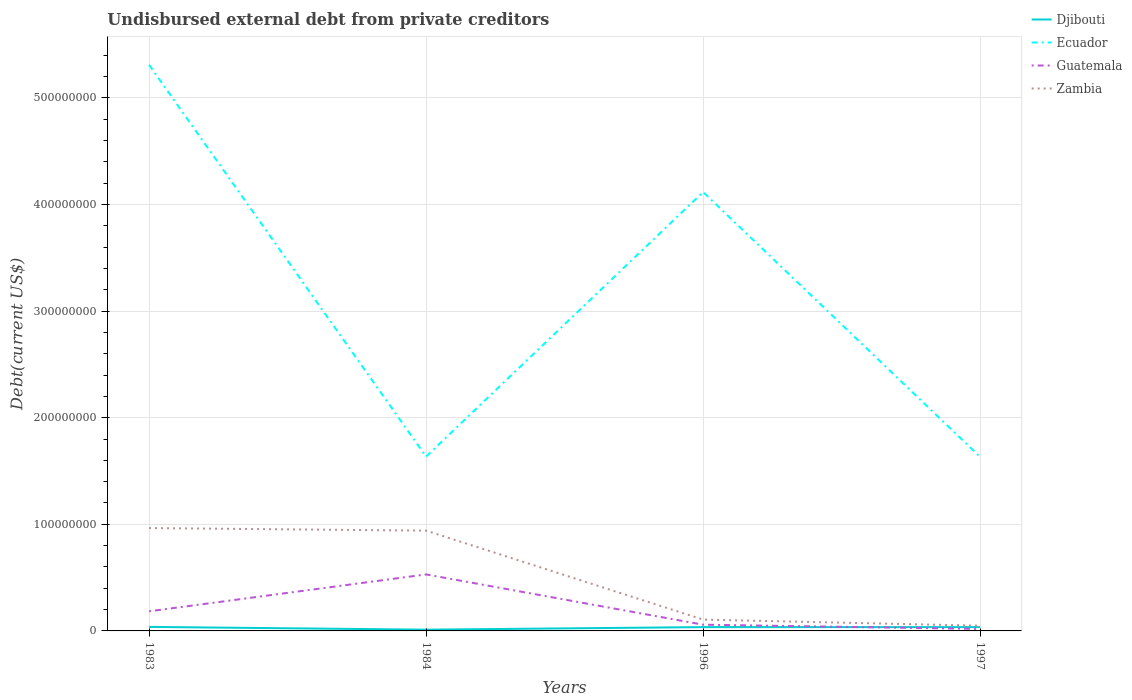Does the line corresponding to Ecuador intersect with the line corresponding to Djibouti?
Make the answer very short. No. Across all years, what is the maximum total debt in Djibouti?
Provide a short and direct response. 1.19e+06. In which year was the total debt in Guatemala maximum?
Give a very brief answer. 1997. What is the total total debt in Zambia in the graph?
Offer a very short reply. 5.72e+06. What is the difference between the highest and the second highest total debt in Djibouti?
Offer a terse response. 2.57e+06. Is the total debt in Guatemala strictly greater than the total debt in Ecuador over the years?
Your answer should be compact. Yes. Where does the legend appear in the graph?
Offer a terse response. Top right. What is the title of the graph?
Give a very brief answer. Undisbursed external debt from private creditors. What is the label or title of the Y-axis?
Your response must be concise. Debt(current US$). What is the Debt(current US$) of Djibouti in 1983?
Offer a terse response. 3.77e+06. What is the Debt(current US$) of Ecuador in 1983?
Your response must be concise. 5.31e+08. What is the Debt(current US$) of Guatemala in 1983?
Ensure brevity in your answer.  1.84e+07. What is the Debt(current US$) in Zambia in 1983?
Make the answer very short. 9.65e+07. What is the Debt(current US$) in Djibouti in 1984?
Your response must be concise. 1.19e+06. What is the Debt(current US$) of Ecuador in 1984?
Offer a terse response. 1.64e+08. What is the Debt(current US$) in Guatemala in 1984?
Your answer should be compact. 5.30e+07. What is the Debt(current US$) of Zambia in 1984?
Provide a succinct answer. 9.41e+07. What is the Debt(current US$) in Djibouti in 1996?
Keep it short and to the point. 3.57e+06. What is the Debt(current US$) of Ecuador in 1996?
Provide a succinct answer. 4.12e+08. What is the Debt(current US$) of Guatemala in 1996?
Offer a terse response. 5.85e+06. What is the Debt(current US$) in Zambia in 1996?
Make the answer very short. 1.06e+07. What is the Debt(current US$) in Djibouti in 1997?
Keep it short and to the point. 3.57e+06. What is the Debt(current US$) of Ecuador in 1997?
Offer a terse response. 1.63e+08. What is the Debt(current US$) in Guatemala in 1997?
Your answer should be compact. 1.84e+06. What is the Debt(current US$) in Zambia in 1997?
Your answer should be very brief. 4.90e+06. Across all years, what is the maximum Debt(current US$) of Djibouti?
Ensure brevity in your answer.  3.77e+06. Across all years, what is the maximum Debt(current US$) of Ecuador?
Ensure brevity in your answer.  5.31e+08. Across all years, what is the maximum Debt(current US$) in Guatemala?
Give a very brief answer. 5.30e+07. Across all years, what is the maximum Debt(current US$) in Zambia?
Your answer should be compact. 9.65e+07. Across all years, what is the minimum Debt(current US$) of Djibouti?
Your answer should be very brief. 1.19e+06. Across all years, what is the minimum Debt(current US$) of Ecuador?
Offer a very short reply. 1.63e+08. Across all years, what is the minimum Debt(current US$) of Guatemala?
Make the answer very short. 1.84e+06. Across all years, what is the minimum Debt(current US$) of Zambia?
Your response must be concise. 4.90e+06. What is the total Debt(current US$) in Djibouti in the graph?
Make the answer very short. 1.21e+07. What is the total Debt(current US$) in Ecuador in the graph?
Provide a short and direct response. 1.27e+09. What is the total Debt(current US$) of Guatemala in the graph?
Offer a very short reply. 7.91e+07. What is the total Debt(current US$) of Zambia in the graph?
Give a very brief answer. 2.06e+08. What is the difference between the Debt(current US$) of Djibouti in 1983 and that in 1984?
Offer a very short reply. 2.57e+06. What is the difference between the Debt(current US$) of Ecuador in 1983 and that in 1984?
Offer a terse response. 3.68e+08. What is the difference between the Debt(current US$) of Guatemala in 1983 and that in 1984?
Your answer should be very brief. -3.46e+07. What is the difference between the Debt(current US$) of Zambia in 1983 and that in 1984?
Ensure brevity in your answer.  2.39e+06. What is the difference between the Debt(current US$) in Djibouti in 1983 and that in 1996?
Offer a very short reply. 1.96e+05. What is the difference between the Debt(current US$) of Ecuador in 1983 and that in 1996?
Keep it short and to the point. 1.19e+08. What is the difference between the Debt(current US$) in Guatemala in 1983 and that in 1996?
Ensure brevity in your answer.  1.25e+07. What is the difference between the Debt(current US$) of Zambia in 1983 and that in 1996?
Your answer should be very brief. 8.59e+07. What is the difference between the Debt(current US$) in Djibouti in 1983 and that in 1997?
Provide a succinct answer. 1.96e+05. What is the difference between the Debt(current US$) in Ecuador in 1983 and that in 1997?
Provide a short and direct response. 3.68e+08. What is the difference between the Debt(current US$) in Guatemala in 1983 and that in 1997?
Keep it short and to the point. 1.65e+07. What is the difference between the Debt(current US$) in Zambia in 1983 and that in 1997?
Ensure brevity in your answer.  9.16e+07. What is the difference between the Debt(current US$) of Djibouti in 1984 and that in 1996?
Ensure brevity in your answer.  -2.38e+06. What is the difference between the Debt(current US$) of Ecuador in 1984 and that in 1996?
Provide a short and direct response. -2.48e+08. What is the difference between the Debt(current US$) in Guatemala in 1984 and that in 1996?
Your response must be concise. 4.71e+07. What is the difference between the Debt(current US$) of Zambia in 1984 and that in 1996?
Offer a terse response. 8.35e+07. What is the difference between the Debt(current US$) in Djibouti in 1984 and that in 1997?
Give a very brief answer. -2.38e+06. What is the difference between the Debt(current US$) in Ecuador in 1984 and that in 1997?
Ensure brevity in your answer.  2.89e+05. What is the difference between the Debt(current US$) in Guatemala in 1984 and that in 1997?
Provide a short and direct response. 5.12e+07. What is the difference between the Debt(current US$) of Zambia in 1984 and that in 1997?
Make the answer very short. 8.92e+07. What is the difference between the Debt(current US$) of Djibouti in 1996 and that in 1997?
Make the answer very short. 0. What is the difference between the Debt(current US$) of Ecuador in 1996 and that in 1997?
Make the answer very short. 2.48e+08. What is the difference between the Debt(current US$) of Guatemala in 1996 and that in 1997?
Keep it short and to the point. 4.01e+06. What is the difference between the Debt(current US$) of Zambia in 1996 and that in 1997?
Provide a succinct answer. 5.72e+06. What is the difference between the Debt(current US$) of Djibouti in 1983 and the Debt(current US$) of Ecuador in 1984?
Provide a short and direct response. -1.60e+08. What is the difference between the Debt(current US$) in Djibouti in 1983 and the Debt(current US$) in Guatemala in 1984?
Make the answer very short. -4.92e+07. What is the difference between the Debt(current US$) in Djibouti in 1983 and the Debt(current US$) in Zambia in 1984?
Offer a terse response. -9.03e+07. What is the difference between the Debt(current US$) of Ecuador in 1983 and the Debt(current US$) of Guatemala in 1984?
Give a very brief answer. 4.78e+08. What is the difference between the Debt(current US$) of Ecuador in 1983 and the Debt(current US$) of Zambia in 1984?
Offer a very short reply. 4.37e+08. What is the difference between the Debt(current US$) in Guatemala in 1983 and the Debt(current US$) in Zambia in 1984?
Your answer should be compact. -7.57e+07. What is the difference between the Debt(current US$) of Djibouti in 1983 and the Debt(current US$) of Ecuador in 1996?
Ensure brevity in your answer.  -4.08e+08. What is the difference between the Debt(current US$) in Djibouti in 1983 and the Debt(current US$) in Guatemala in 1996?
Keep it short and to the point. -2.08e+06. What is the difference between the Debt(current US$) in Djibouti in 1983 and the Debt(current US$) in Zambia in 1996?
Give a very brief answer. -6.85e+06. What is the difference between the Debt(current US$) in Ecuador in 1983 and the Debt(current US$) in Guatemala in 1996?
Your response must be concise. 5.25e+08. What is the difference between the Debt(current US$) in Ecuador in 1983 and the Debt(current US$) in Zambia in 1996?
Your answer should be compact. 5.20e+08. What is the difference between the Debt(current US$) in Guatemala in 1983 and the Debt(current US$) in Zambia in 1996?
Ensure brevity in your answer.  7.77e+06. What is the difference between the Debt(current US$) in Djibouti in 1983 and the Debt(current US$) in Ecuador in 1997?
Offer a very short reply. -1.59e+08. What is the difference between the Debt(current US$) of Djibouti in 1983 and the Debt(current US$) of Guatemala in 1997?
Your response must be concise. 1.92e+06. What is the difference between the Debt(current US$) of Djibouti in 1983 and the Debt(current US$) of Zambia in 1997?
Provide a succinct answer. -1.13e+06. What is the difference between the Debt(current US$) in Ecuador in 1983 and the Debt(current US$) in Guatemala in 1997?
Offer a very short reply. 5.29e+08. What is the difference between the Debt(current US$) of Ecuador in 1983 and the Debt(current US$) of Zambia in 1997?
Keep it short and to the point. 5.26e+08. What is the difference between the Debt(current US$) of Guatemala in 1983 and the Debt(current US$) of Zambia in 1997?
Make the answer very short. 1.35e+07. What is the difference between the Debt(current US$) in Djibouti in 1984 and the Debt(current US$) in Ecuador in 1996?
Keep it short and to the point. -4.11e+08. What is the difference between the Debt(current US$) of Djibouti in 1984 and the Debt(current US$) of Guatemala in 1996?
Keep it short and to the point. -4.66e+06. What is the difference between the Debt(current US$) of Djibouti in 1984 and the Debt(current US$) of Zambia in 1996?
Offer a terse response. -9.42e+06. What is the difference between the Debt(current US$) of Ecuador in 1984 and the Debt(current US$) of Guatemala in 1996?
Keep it short and to the point. 1.58e+08. What is the difference between the Debt(current US$) of Ecuador in 1984 and the Debt(current US$) of Zambia in 1996?
Make the answer very short. 1.53e+08. What is the difference between the Debt(current US$) of Guatemala in 1984 and the Debt(current US$) of Zambia in 1996?
Your response must be concise. 4.24e+07. What is the difference between the Debt(current US$) in Djibouti in 1984 and the Debt(current US$) in Ecuador in 1997?
Make the answer very short. -1.62e+08. What is the difference between the Debt(current US$) of Djibouti in 1984 and the Debt(current US$) of Guatemala in 1997?
Provide a short and direct response. -6.52e+05. What is the difference between the Debt(current US$) of Djibouti in 1984 and the Debt(current US$) of Zambia in 1997?
Give a very brief answer. -3.71e+06. What is the difference between the Debt(current US$) of Ecuador in 1984 and the Debt(current US$) of Guatemala in 1997?
Make the answer very short. 1.62e+08. What is the difference between the Debt(current US$) in Ecuador in 1984 and the Debt(current US$) in Zambia in 1997?
Offer a very short reply. 1.59e+08. What is the difference between the Debt(current US$) in Guatemala in 1984 and the Debt(current US$) in Zambia in 1997?
Give a very brief answer. 4.81e+07. What is the difference between the Debt(current US$) in Djibouti in 1996 and the Debt(current US$) in Ecuador in 1997?
Offer a very short reply. -1.60e+08. What is the difference between the Debt(current US$) in Djibouti in 1996 and the Debt(current US$) in Guatemala in 1997?
Provide a short and direct response. 1.73e+06. What is the difference between the Debt(current US$) of Djibouti in 1996 and the Debt(current US$) of Zambia in 1997?
Offer a terse response. -1.33e+06. What is the difference between the Debt(current US$) of Ecuador in 1996 and the Debt(current US$) of Guatemala in 1997?
Provide a succinct answer. 4.10e+08. What is the difference between the Debt(current US$) of Ecuador in 1996 and the Debt(current US$) of Zambia in 1997?
Ensure brevity in your answer.  4.07e+08. What is the difference between the Debt(current US$) of Guatemala in 1996 and the Debt(current US$) of Zambia in 1997?
Give a very brief answer. 9.51e+05. What is the average Debt(current US$) in Djibouti per year?
Offer a very short reply. 3.02e+06. What is the average Debt(current US$) of Ecuador per year?
Provide a succinct answer. 3.17e+08. What is the average Debt(current US$) in Guatemala per year?
Provide a succinct answer. 1.98e+07. What is the average Debt(current US$) of Zambia per year?
Ensure brevity in your answer.  5.15e+07. In the year 1983, what is the difference between the Debt(current US$) of Djibouti and Debt(current US$) of Ecuador?
Make the answer very short. -5.27e+08. In the year 1983, what is the difference between the Debt(current US$) in Djibouti and Debt(current US$) in Guatemala?
Your answer should be very brief. -1.46e+07. In the year 1983, what is the difference between the Debt(current US$) in Djibouti and Debt(current US$) in Zambia?
Give a very brief answer. -9.27e+07. In the year 1983, what is the difference between the Debt(current US$) in Ecuador and Debt(current US$) in Guatemala?
Offer a very short reply. 5.13e+08. In the year 1983, what is the difference between the Debt(current US$) of Ecuador and Debt(current US$) of Zambia?
Your response must be concise. 4.35e+08. In the year 1983, what is the difference between the Debt(current US$) in Guatemala and Debt(current US$) in Zambia?
Provide a short and direct response. -7.81e+07. In the year 1984, what is the difference between the Debt(current US$) in Djibouti and Debt(current US$) in Ecuador?
Ensure brevity in your answer.  -1.62e+08. In the year 1984, what is the difference between the Debt(current US$) in Djibouti and Debt(current US$) in Guatemala?
Provide a short and direct response. -5.18e+07. In the year 1984, what is the difference between the Debt(current US$) of Djibouti and Debt(current US$) of Zambia?
Offer a terse response. -9.29e+07. In the year 1984, what is the difference between the Debt(current US$) in Ecuador and Debt(current US$) in Guatemala?
Offer a very short reply. 1.11e+08. In the year 1984, what is the difference between the Debt(current US$) in Ecuador and Debt(current US$) in Zambia?
Offer a terse response. 6.94e+07. In the year 1984, what is the difference between the Debt(current US$) in Guatemala and Debt(current US$) in Zambia?
Your response must be concise. -4.11e+07. In the year 1996, what is the difference between the Debt(current US$) of Djibouti and Debt(current US$) of Ecuador?
Offer a terse response. -4.08e+08. In the year 1996, what is the difference between the Debt(current US$) in Djibouti and Debt(current US$) in Guatemala?
Your answer should be very brief. -2.28e+06. In the year 1996, what is the difference between the Debt(current US$) of Djibouti and Debt(current US$) of Zambia?
Offer a terse response. -7.05e+06. In the year 1996, what is the difference between the Debt(current US$) of Ecuador and Debt(current US$) of Guatemala?
Keep it short and to the point. 4.06e+08. In the year 1996, what is the difference between the Debt(current US$) in Ecuador and Debt(current US$) in Zambia?
Offer a terse response. 4.01e+08. In the year 1996, what is the difference between the Debt(current US$) in Guatemala and Debt(current US$) in Zambia?
Make the answer very short. -4.77e+06. In the year 1997, what is the difference between the Debt(current US$) in Djibouti and Debt(current US$) in Ecuador?
Offer a very short reply. -1.60e+08. In the year 1997, what is the difference between the Debt(current US$) of Djibouti and Debt(current US$) of Guatemala?
Provide a short and direct response. 1.73e+06. In the year 1997, what is the difference between the Debt(current US$) of Djibouti and Debt(current US$) of Zambia?
Provide a succinct answer. -1.33e+06. In the year 1997, what is the difference between the Debt(current US$) in Ecuador and Debt(current US$) in Guatemala?
Offer a very short reply. 1.61e+08. In the year 1997, what is the difference between the Debt(current US$) of Ecuador and Debt(current US$) of Zambia?
Provide a succinct answer. 1.58e+08. In the year 1997, what is the difference between the Debt(current US$) of Guatemala and Debt(current US$) of Zambia?
Offer a very short reply. -3.06e+06. What is the ratio of the Debt(current US$) in Djibouti in 1983 to that in 1984?
Provide a succinct answer. 3.16. What is the ratio of the Debt(current US$) in Ecuador in 1983 to that in 1984?
Keep it short and to the point. 3.25. What is the ratio of the Debt(current US$) of Guatemala in 1983 to that in 1984?
Make the answer very short. 0.35. What is the ratio of the Debt(current US$) in Zambia in 1983 to that in 1984?
Keep it short and to the point. 1.03. What is the ratio of the Debt(current US$) of Djibouti in 1983 to that in 1996?
Your response must be concise. 1.05. What is the ratio of the Debt(current US$) in Ecuador in 1983 to that in 1996?
Offer a very short reply. 1.29. What is the ratio of the Debt(current US$) in Guatemala in 1983 to that in 1996?
Give a very brief answer. 3.14. What is the ratio of the Debt(current US$) of Zambia in 1983 to that in 1996?
Ensure brevity in your answer.  9.09. What is the ratio of the Debt(current US$) in Djibouti in 1983 to that in 1997?
Your response must be concise. 1.05. What is the ratio of the Debt(current US$) in Ecuador in 1983 to that in 1997?
Ensure brevity in your answer.  3.25. What is the ratio of the Debt(current US$) of Guatemala in 1983 to that in 1997?
Make the answer very short. 9.97. What is the ratio of the Debt(current US$) of Zambia in 1983 to that in 1997?
Give a very brief answer. 19.69. What is the ratio of the Debt(current US$) of Djibouti in 1984 to that in 1996?
Ensure brevity in your answer.  0.33. What is the ratio of the Debt(current US$) in Ecuador in 1984 to that in 1996?
Offer a terse response. 0.4. What is the ratio of the Debt(current US$) in Guatemala in 1984 to that in 1996?
Your answer should be very brief. 9.06. What is the ratio of the Debt(current US$) of Zambia in 1984 to that in 1996?
Provide a succinct answer. 8.86. What is the ratio of the Debt(current US$) in Djibouti in 1984 to that in 1997?
Your response must be concise. 0.33. What is the ratio of the Debt(current US$) of Ecuador in 1984 to that in 1997?
Make the answer very short. 1. What is the ratio of the Debt(current US$) of Guatemala in 1984 to that in 1997?
Your answer should be compact. 28.74. What is the ratio of the Debt(current US$) of Zambia in 1984 to that in 1997?
Your answer should be very brief. 19.2. What is the ratio of the Debt(current US$) of Ecuador in 1996 to that in 1997?
Your answer should be compact. 2.52. What is the ratio of the Debt(current US$) of Guatemala in 1996 to that in 1997?
Give a very brief answer. 3.17. What is the ratio of the Debt(current US$) of Zambia in 1996 to that in 1997?
Provide a succinct answer. 2.17. What is the difference between the highest and the second highest Debt(current US$) in Djibouti?
Provide a succinct answer. 1.96e+05. What is the difference between the highest and the second highest Debt(current US$) of Ecuador?
Provide a succinct answer. 1.19e+08. What is the difference between the highest and the second highest Debt(current US$) of Guatemala?
Give a very brief answer. 3.46e+07. What is the difference between the highest and the second highest Debt(current US$) of Zambia?
Make the answer very short. 2.39e+06. What is the difference between the highest and the lowest Debt(current US$) of Djibouti?
Ensure brevity in your answer.  2.57e+06. What is the difference between the highest and the lowest Debt(current US$) in Ecuador?
Your answer should be very brief. 3.68e+08. What is the difference between the highest and the lowest Debt(current US$) of Guatemala?
Provide a short and direct response. 5.12e+07. What is the difference between the highest and the lowest Debt(current US$) of Zambia?
Offer a terse response. 9.16e+07. 